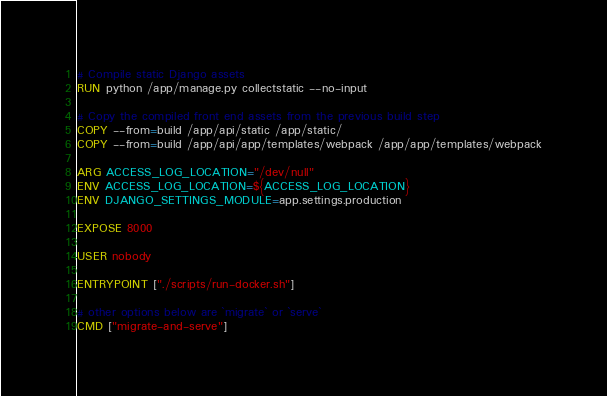Convert code to text. <code><loc_0><loc_0><loc_500><loc_500><_Dockerfile_>
# Compile static Django assets
RUN python /app/manage.py collectstatic --no-input

# Copy the compiled front end assets from the previous build step
COPY --from=build /app/api/static /app/static/
COPY --from=build /app/api/app/templates/webpack /app/app/templates/webpack

ARG ACCESS_LOG_LOCATION="/dev/null"
ENV ACCESS_LOG_LOCATION=${ACCESS_LOG_LOCATION}
ENV DJANGO_SETTINGS_MODULE=app.settings.production

EXPOSE 8000

USER nobody

ENTRYPOINT ["./scripts/run-docker.sh"]

# other options below are `migrate` or `serve`
CMD ["migrate-and-serve"]
</code> 